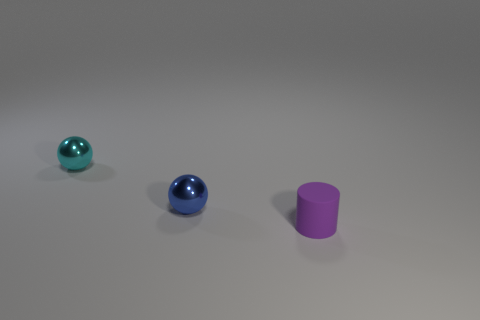Add 3 small gray rubber cylinders. How many objects exist? 6 Subtract 0 gray spheres. How many objects are left? 3 Subtract all cylinders. How many objects are left? 2 Subtract 1 spheres. How many spheres are left? 1 Subtract all yellow balls. Subtract all brown blocks. How many balls are left? 2 Subtract all yellow cylinders. How many cyan spheres are left? 1 Subtract all cyan objects. Subtract all tiny metallic balls. How many objects are left? 0 Add 2 tiny cylinders. How many tiny cylinders are left? 3 Add 1 small brown rubber balls. How many small brown rubber balls exist? 1 